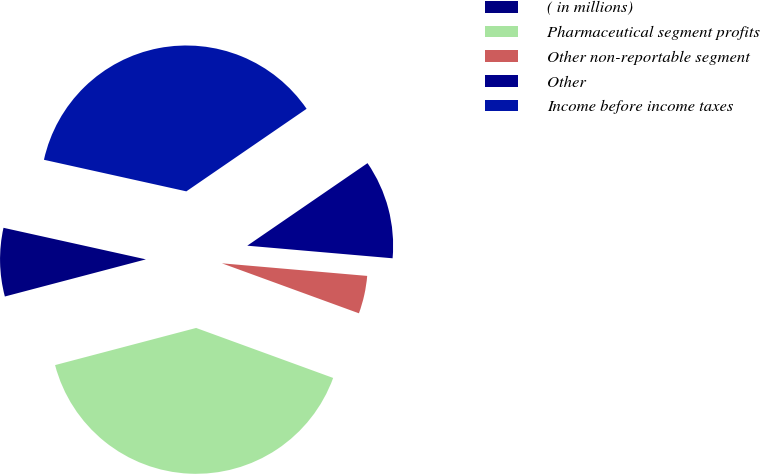Convert chart to OTSL. <chart><loc_0><loc_0><loc_500><loc_500><pie_chart><fcel>( in millions)<fcel>Pharmaceutical segment profits<fcel>Other non-reportable segment<fcel>Other<fcel>Income before income taxes<nl><fcel>7.57%<fcel>40.33%<fcel>4.19%<fcel>10.95%<fcel>36.95%<nl></chart> 